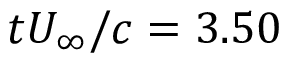Convert formula to latex. <formula><loc_0><loc_0><loc_500><loc_500>t U _ { \infty } / c = 3 . 5 0</formula> 